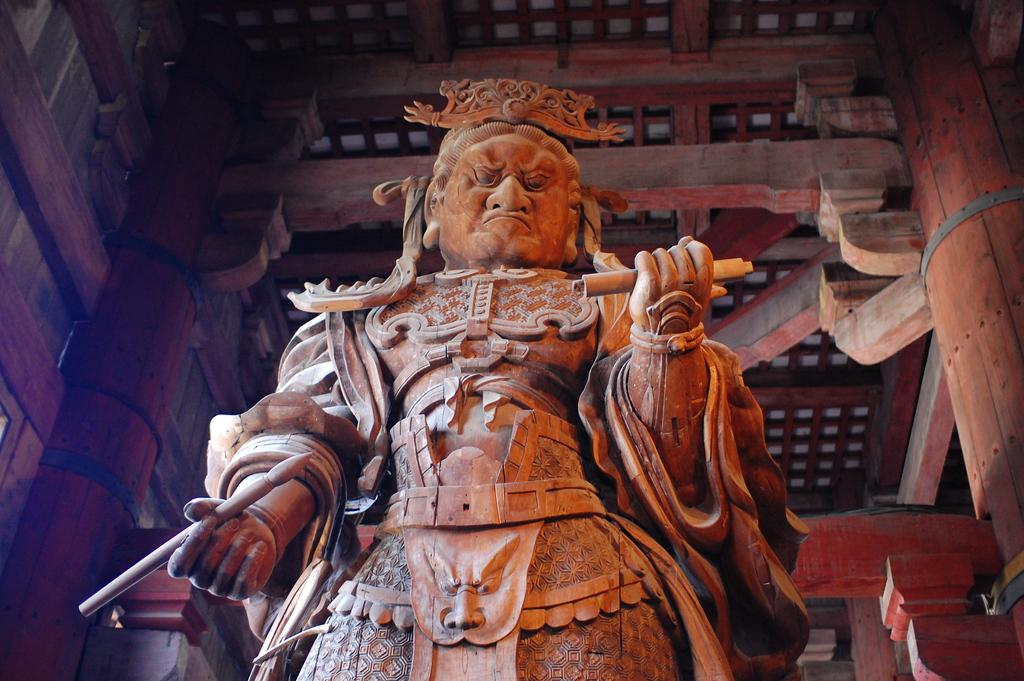What is the main subject of the image? There is a statue in the image. What is the color of the statue? The statue is brown in color. What can be seen in the background of the image? There are wooden pillars in the background of the image. What type of insurance is the statue holding in the image? There is no insurance present in the image; the statue is not holding anything. 